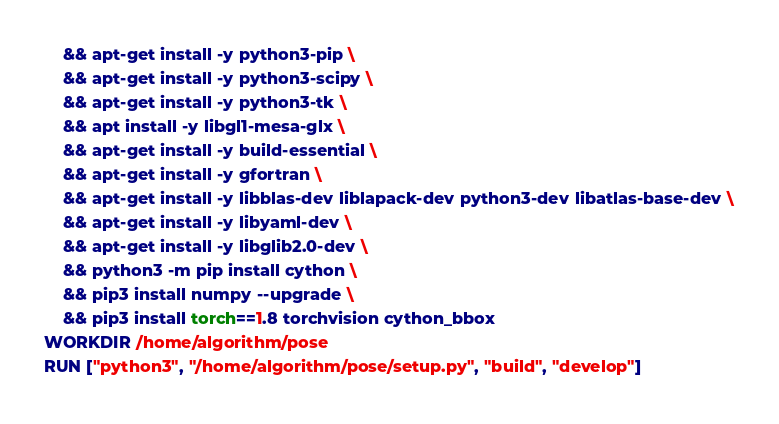Convert code to text. <code><loc_0><loc_0><loc_500><loc_500><_Dockerfile_>    && apt-get install -y python3-pip \ 
    && apt-get install -y python3-scipy \
    && apt-get install -y python3-tk \  
    && apt install -y libgl1-mesa-glx \ 
    && apt-get install -y build-essential \ 
    && apt-get install -y gfortran \ 
    && apt-get install -y libblas-dev liblapack-dev python3-dev libatlas-base-dev \
    && apt-get install -y libyaml-dev \
    && apt-get install -y libglib2.0-dev \
    && python3 -m pip install cython \
    && pip3 install numpy --upgrade \
    && pip3 install torch==1.8 torchvision cython_bbox
WORKDIR /home/algorithm/pose
RUN ["python3", "/home/algorithm/pose/setup.py", "build", "develop"]
</code> 